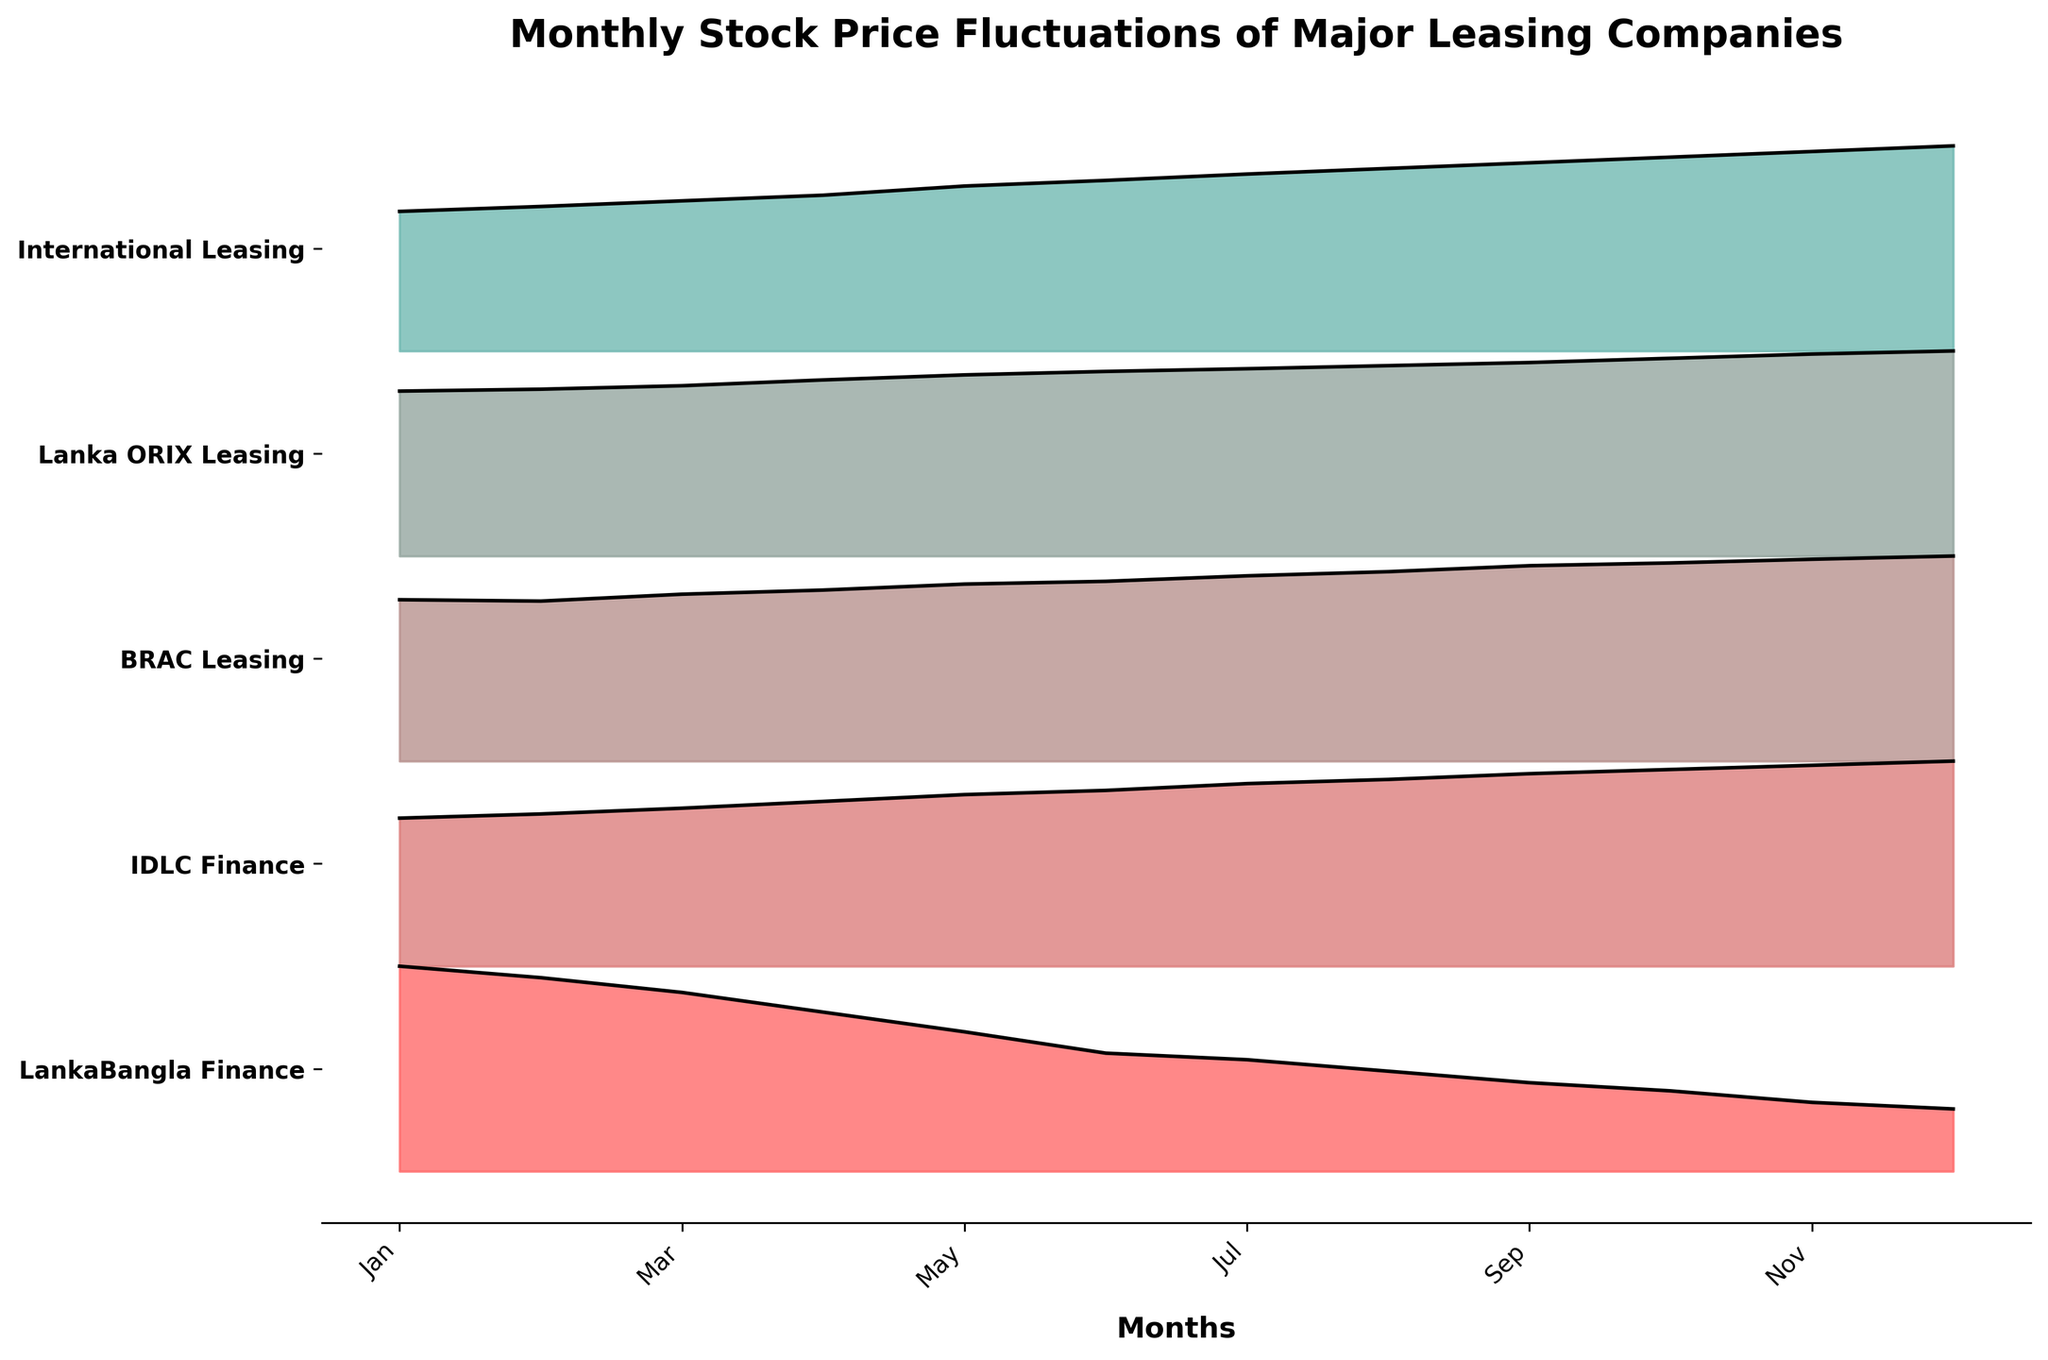How many leasing companies are represented in the plot? Count the number of companies listed on the y-axis.
Answer: 5 What is the title of the plot? Read the title directly from the top of the plot.
Answer: Monthly Stock Price Fluctuations of Major Leasing Companies Which company shows the highest stock price for the month of January? Compare the filled areas and their peak positions for January, focusing on the highest value.
Answer: IDLC Finance How do the stock prices of International Leasing and LankaBangla Finance compare in December? Locate the December column and compare the heights of the filled areas for International Leasing and LankaBangla Finance. International Leasing has a lower height.
Answer: LankaBangla Finance's stock price is higher What is the average stock price of BRAC Leasing over the year? Sum the stock prices of BRAC Leasing for all months and divide by 12. \((35.1 + 34.8 + 36.3 + 37.2 + 38.5 + 39.1 + 40.3 + 41.2 + 42.5 + 43.1 + 43.9 + 44.6)/12\approx 39.25\)
Answer: 39.25 Which month shows the biggest drop in the stock price of International Leasing compared to the previous month? Subtract the stock price of each month from the previous month for International Leasing and find the largest negative difference. \((Jan - Feb) = -0.7, (Feb - Mar) = -0.9, (Mar - Apr) = -1.2, (Apr - May) = -1.2, (May - Jun) = -1.3, (Jun - Jul) = -0.4, (Jul - Aug) = -0.7, (Aug - Sep) = -0.7, (Sep - Oct) = -0.5, (Oct - Nov) = -0.7, (Nov - Dec) = -0.4\). The biggest drop is between May and June (-1.3).
Answer: June What is the stock price trend for IDLC Finance throughout the year? Observe the slope and direction of the line for IDLC Finance across all months. The line increases with time.
Answer: Increasing trend Is there any month where all companies have a stock price above 20? Check each month's vertical line to see if all filled areas are above the height representing 20 on the relative scale.
Answer: No In which month does Lanka ORIX Leasing have its highest stock price? Identify the peak of the filled area for Lanka ORIX Leasing and note the corresponding month.
Answer: December 